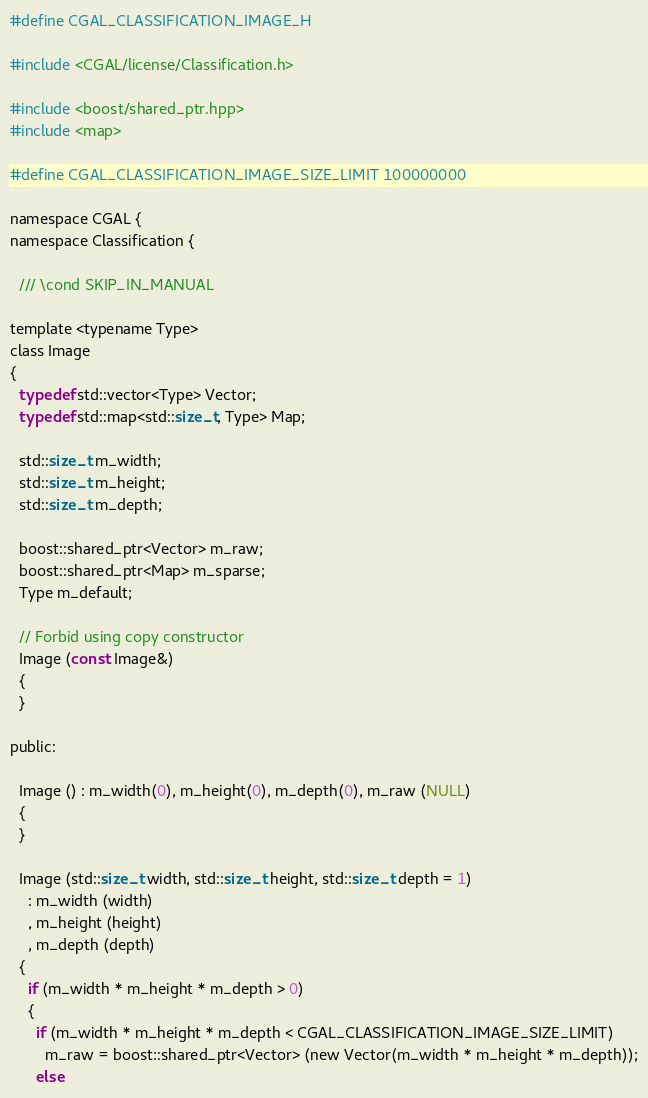Convert code to text. <code><loc_0><loc_0><loc_500><loc_500><_C_>#define CGAL_CLASSIFICATION_IMAGE_H

#include <CGAL/license/Classification.h>

#include <boost/shared_ptr.hpp>
#include <map>

#define CGAL_CLASSIFICATION_IMAGE_SIZE_LIMIT 100000000

namespace CGAL {
namespace Classification {

  /// \cond SKIP_IN_MANUAL
  
template <typename Type>
class Image
{
  typedef std::vector<Type> Vector;
  typedef std::map<std::size_t, Type> Map;
  
  std::size_t m_width;
  std::size_t m_height;
  std::size_t m_depth;
  
  boost::shared_ptr<Vector> m_raw;
  boost::shared_ptr<Map> m_sparse;
  Type m_default;

  // Forbid using copy constructor
  Image (const Image&)
  {
  }
  
public:

  Image () : m_width(0), m_height(0), m_depth(0), m_raw (NULL)
  {
  }
  
  Image (std::size_t width, std::size_t height, std::size_t depth = 1)
    : m_width (width)
    , m_height (height)
    , m_depth (depth)
  {
    if (m_width * m_height * m_depth > 0)
    {
      if (m_width * m_height * m_depth < CGAL_CLASSIFICATION_IMAGE_SIZE_LIMIT)
        m_raw = boost::shared_ptr<Vector> (new Vector(m_width * m_height * m_depth));
      else</code> 